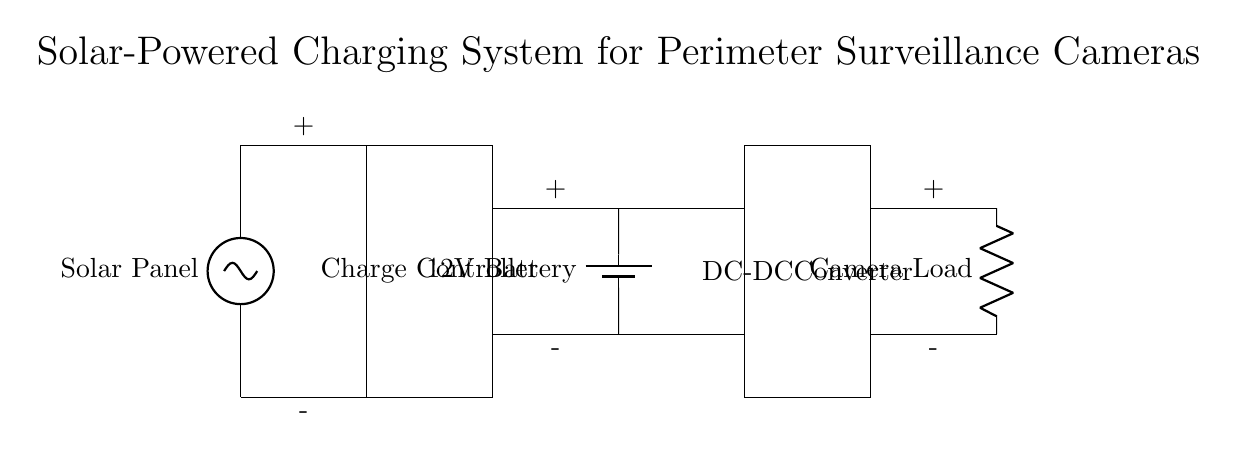What type of power source is used in this charging system? The circuit diagram indicates the presence of a solar panel, which is a renewable energy source used in this system to charge the battery.
Answer: Solar Panel What does the charge controller do in this circuit? The charge controller regulates the voltage and current coming from the solar panel to ensure that the battery is charged properly, preventing overcharging or damage.
Answer: Regulates charge What is the output voltage of the battery in this circuit? The battery shown in the diagram is labeled as a 12V battery, meaning it outputs a voltage of 12 volts when fully charged.
Answer: 12 volts What component converts the battery voltage to a different level? The DC-DC converter is responsible for adjusting the output voltage from the battery to the required level for the camera load.
Answer: DC-DC Converter What is the load being powered by the system? The diagram shows the camera load connected to the battery through the DC-DC converter, indicating that this is the device that utilizes the power supplied by the system.
Answer: Camera Load Why is a battery included in the system design? The battery stores energy from the solar panel and provides power to the camera load during times when the solar panel cannot produce power, such as at night or on cloudy days.
Answer: Energy storage What role does the solar panel play in relation to the battery? The solar panel charges the battery by converting sunlight into electrical energy, which is then stored for later use by the camera load.
Answer: Charges battery 